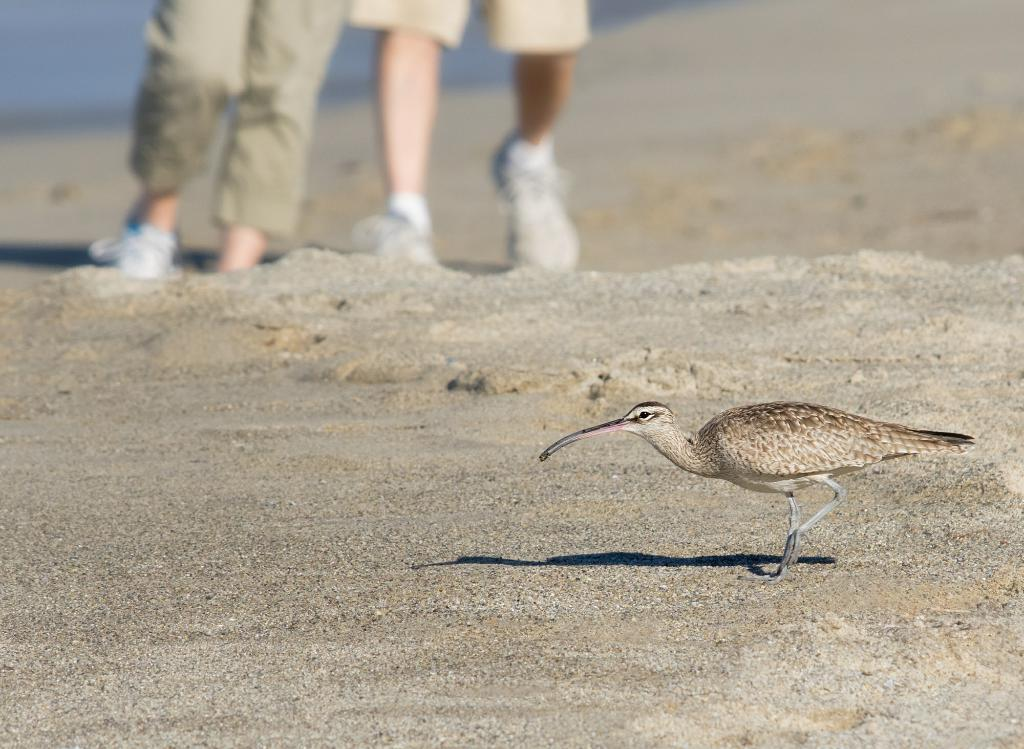What is the main subject in the foreground of the image? There is a bird in the foreground of the image. What is the bird standing on? The bird is on the sand. Can you see any human presence in the image? Yes, there are legs of a person visible at the top of the image. How many light bulbs are hanging from the bird's beak in the image? There are no light bulbs present in the image, and the bird's beak is not holding any objects. What type of planes can be seen flying in the background of the image? There are no planes visible in the image; it features a bird on the sand and a person's legs. 